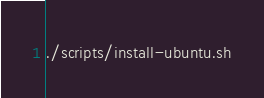<code> <loc_0><loc_0><loc_500><loc_500><_Bash_>./scripts/install-ubuntu.sh

</code> 